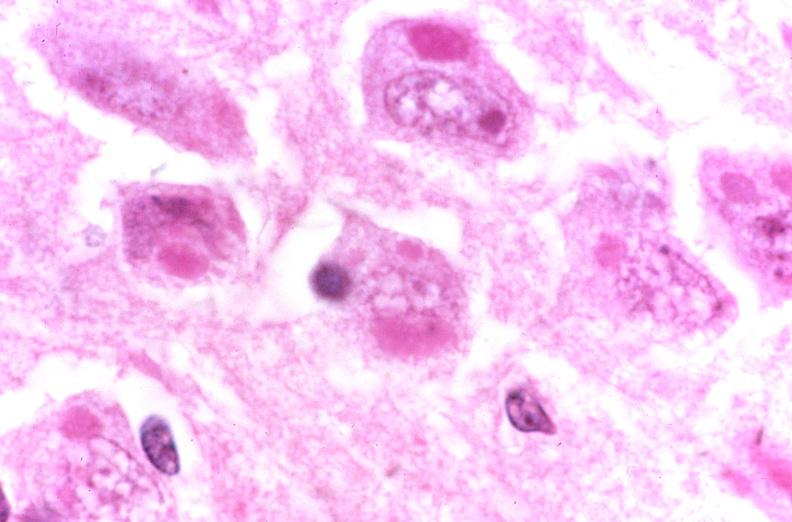s normal present?
Answer the question using a single word or phrase. No 